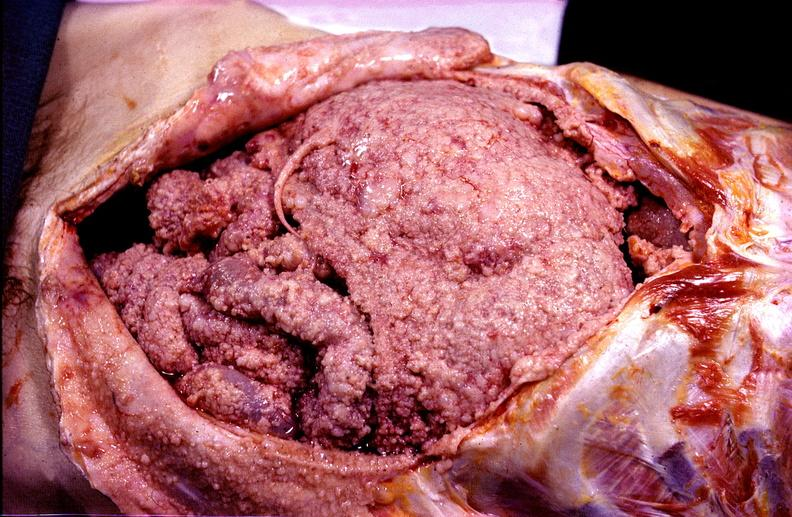does this image show peritoneal carcinomatosis, metastatic tumor covering all of the abdominal viscera?
Answer the question using a single word or phrase. Yes 